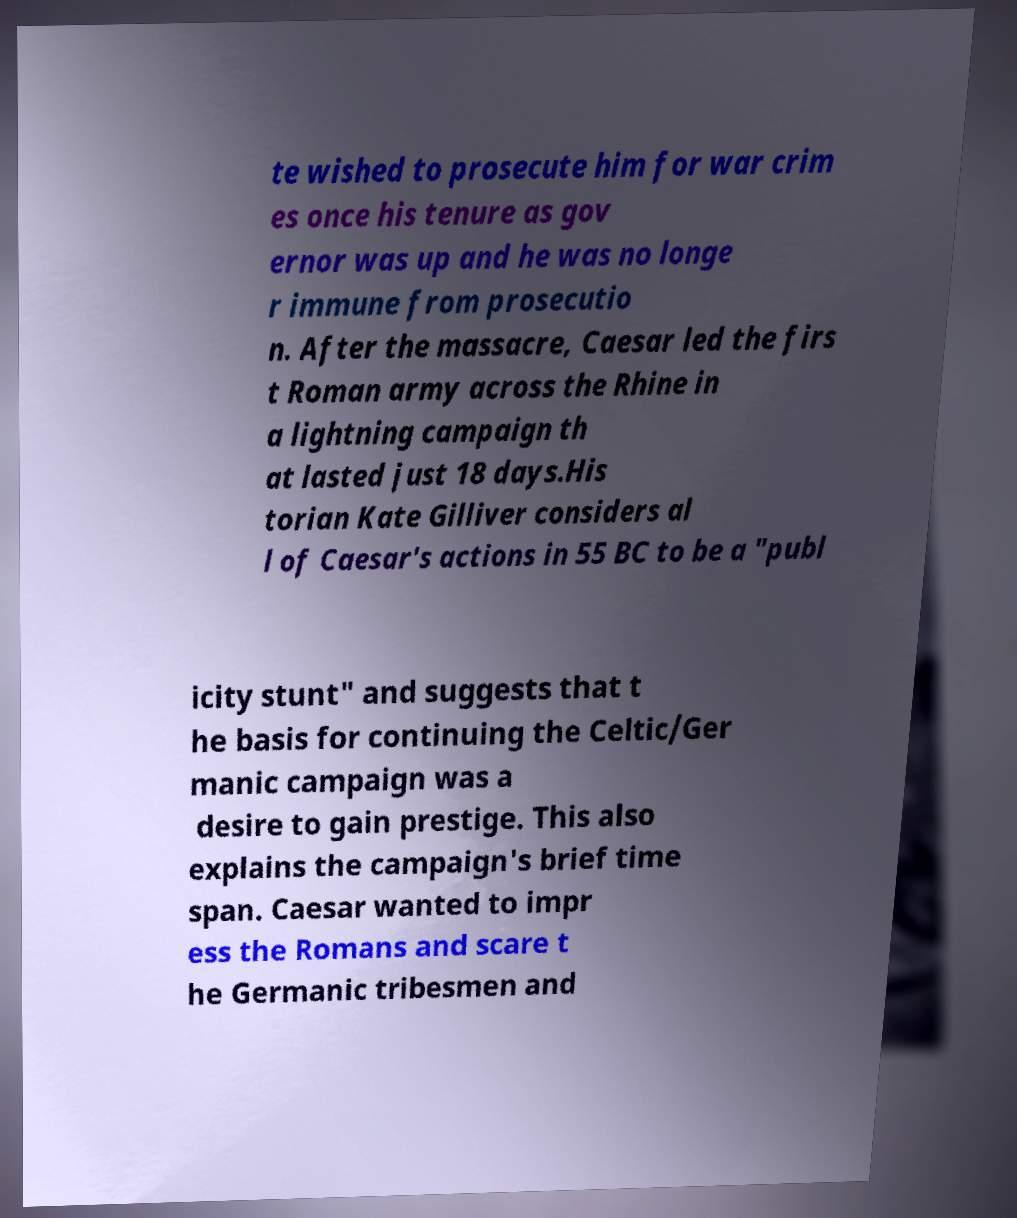Can you accurately transcribe the text from the provided image for me? te wished to prosecute him for war crim es once his tenure as gov ernor was up and he was no longe r immune from prosecutio n. After the massacre, Caesar led the firs t Roman army across the Rhine in a lightning campaign th at lasted just 18 days.His torian Kate Gilliver considers al l of Caesar's actions in 55 BC to be a "publ icity stunt" and suggests that t he basis for continuing the Celtic/Ger manic campaign was a desire to gain prestige. This also explains the campaign's brief time span. Caesar wanted to impr ess the Romans and scare t he Germanic tribesmen and 